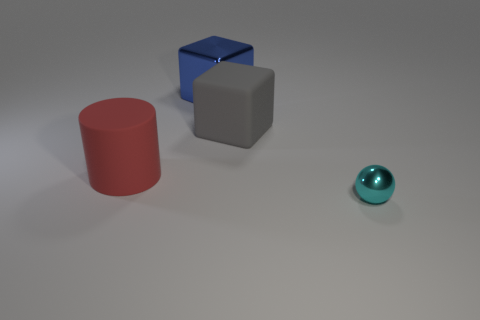What material do the objects seem to be made of? The objects appear to have different textures. The red cylinder and the two cubes look like they have a matte finish, suggesting they could be made of a material like painted wood or plastic. The cyan sphere has a reflective, glossy finish, indicating it might be made of polished metal or glass. 